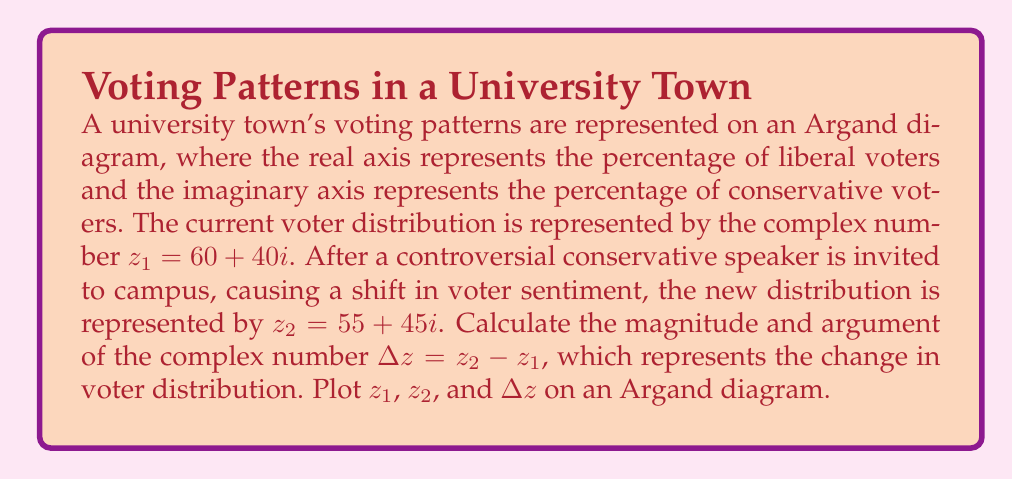Help me with this question. To solve this problem, we'll follow these steps:

1) First, calculate $\Delta z$:
   $\Delta z = z_2 - z_1 = (55 + 45i) - (60 + 40i) = -5 + 5i$

2) To find the magnitude of $\Delta z$, we use the formula:
   $|\Delta z| = \sqrt{(\text{Re}(\Delta z))^2 + (\text{Im}(\Delta z))^2}$
   $|\Delta z| = \sqrt{(-5)^2 + 5^2} = \sqrt{50} = 5\sqrt{2}$

3) To find the argument of $\Delta z$, we use the arctangent function:
   $\arg(\Delta z) = \tan^{-1}(\frac{\text{Im}(\Delta z)}{\text{Re}(\Delta z)})$
   $\arg(\Delta z) = \tan^{-1}(\frac{5}{-5}) = \tan^{-1}(-1) = -\frac{\pi}{4}$
   However, since the real part is negative and the imaginary part is positive, we need to add $\pi$ to this result:
   $\arg(\Delta z) = -\frac{\pi}{4} + \pi = \frac{3\pi}{4}$

4) Now, let's plot these points on an Argand diagram:

[asy]
import graph;
size(200);
real[] ticksX={-20,0,20,40,60,80};
real[] ticksY={-20,0,20,40,60,80};
xaxis("Re",Ticks(ticksX));
yaxis("Im",Ticks(ticksY));

dot((60,40),red);
label("$z_1$",(60,40),NE,red);
dot((55,45),blue);
label("$z_2$",(55,45),NE,blue);
draw((60,40)--(55,45),green,Arrow);
dot((-5,5),green);
label("$\Delta z$",(-5,5),NW,green);

draw((-10,0)--(80,0),gray);
draw((0,-10)--(0,80),gray);
[/asy]

The green arrow represents the shift from $z_1$ to $z_2$, which is equivalent to $\Delta z$.
Answer: The magnitude of $\Delta z$ is $5\sqrt{2}$, and its argument is $\frac{3\pi}{4}$ radians. 